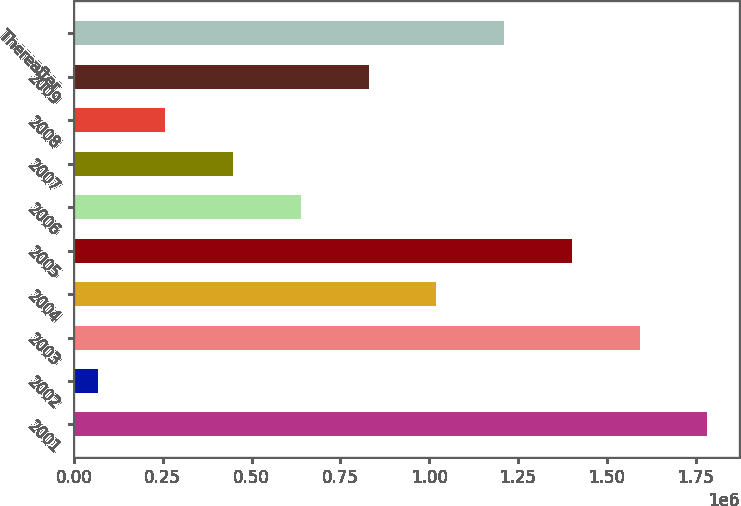<chart> <loc_0><loc_0><loc_500><loc_500><bar_chart><fcel>2001<fcel>2002<fcel>2003<fcel>2004<fcel>2005<fcel>2006<fcel>2007<fcel>2008<fcel>2009<fcel>Thereafter<nl><fcel>1.78258e+06<fcel>66847<fcel>1.59194e+06<fcel>1.02003e+06<fcel>1.4013e+06<fcel>638757<fcel>448121<fcel>257484<fcel>829394<fcel>1.21067e+06<nl></chart> 